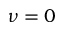Convert formula to latex. <formula><loc_0><loc_0><loc_500><loc_500>\nu = 0</formula> 